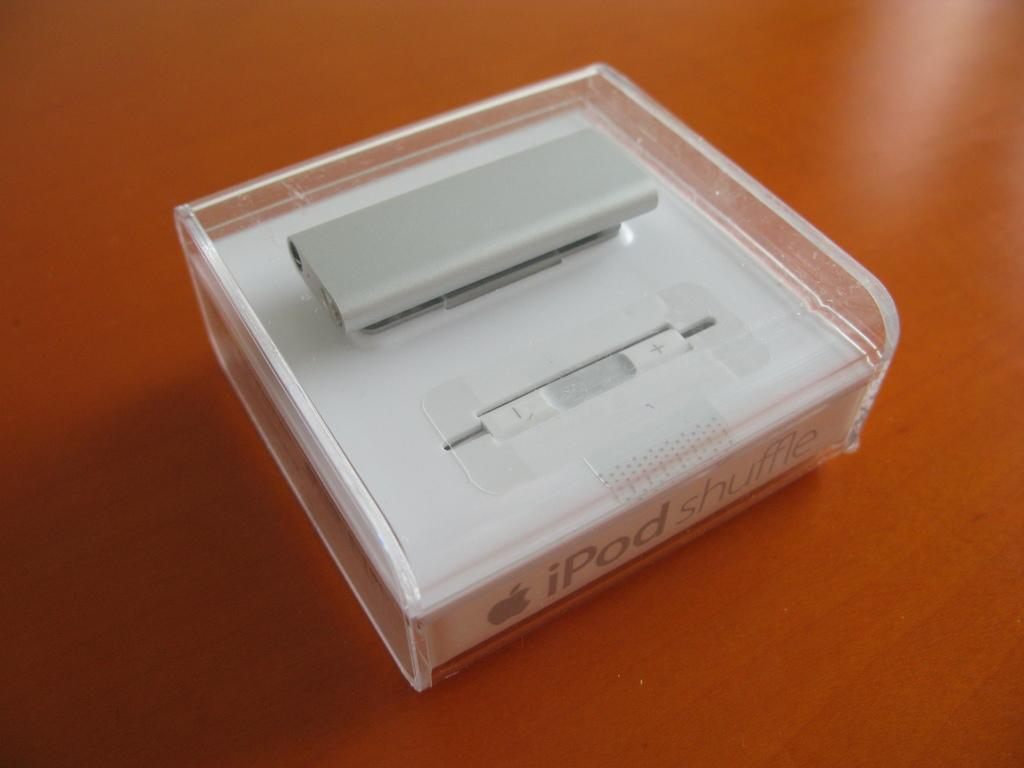<image>
Provide a brief description of the given image. an ipod shuffle, still in its sealed box 